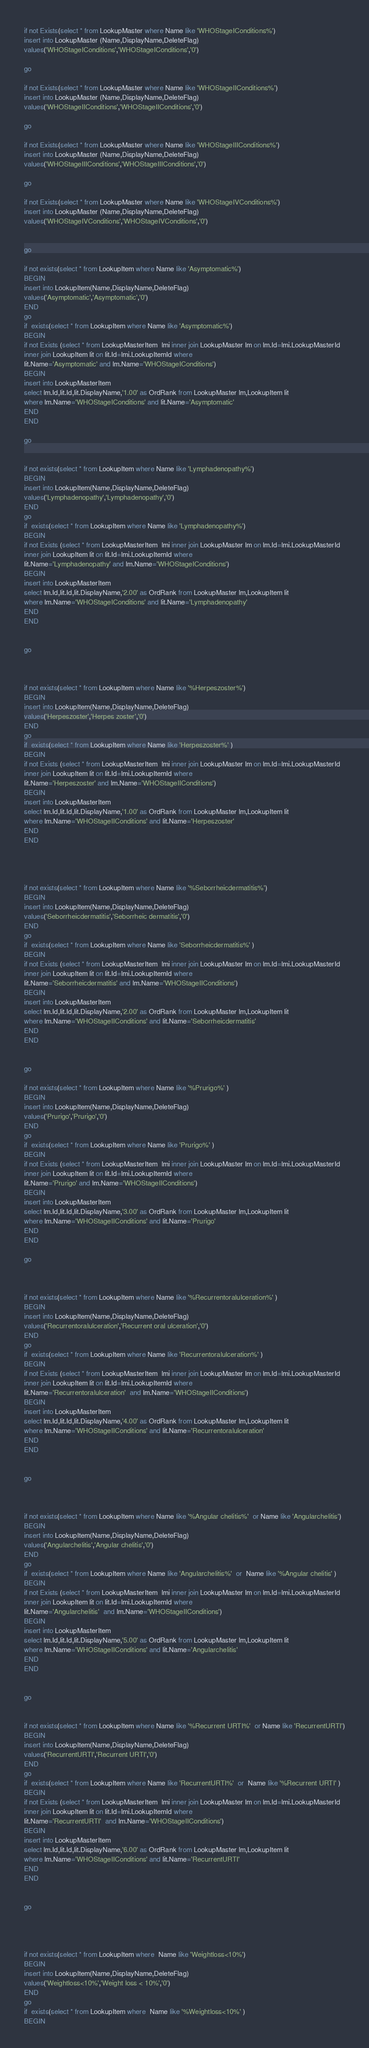<code> <loc_0><loc_0><loc_500><loc_500><_SQL_>if not Exists(select * from LookupMaster where Name like 'WHOStageIConditions%')
insert into LookupMaster (Name,DisplayName,DeleteFlag)
values('WHOStageIConditions','WHOStageIConditions','0')

go

if not Exists(select * from LookupMaster where Name like 'WHOStageIIConditions%')
insert into LookupMaster (Name,DisplayName,DeleteFlag)
values('WHOStageIIConditions','WHOStageIIConditions','0')

go

if not Exists(select * from LookupMaster where Name like 'WHOStageIIIConditions%')
insert into LookupMaster (Name,DisplayName,DeleteFlag)
values('WHOStageIIIConditions','WHOStageIIIConditions','0')

go

if not Exists(select * from LookupMaster where Name like 'WHOStageIVConditions%')
insert into LookupMaster (Name,DisplayName,DeleteFlag)
values('WHOStageIVConditions','WHOStageIVConditions','0')


go

if not exists(select * from LookupItem where Name like 'Asymptomatic%')
BEGIN
insert into LookupItem(Name,DisplayName,DeleteFlag)
values('Asymptomatic','Asymptomatic','0')
END
go
if  exists(select * from LookupItem where Name like 'Asymptomatic%')
BEGIN
if not Exists (select * from LookupMasterItem  lmi inner join LookupMaster lm on lm.Id=lmi.LookupMasterId
inner join LookupItem lit on lit.Id=lmi.LookupItemId where 
lit.Name='Asymptomatic' and lm.Name='WHOStageIConditions')
BEGIN
insert into LookupMasterItem 
select lm.Id,lit.Id,lit.DisplayName,'1.00' as OrdRank from LookupMaster lm,LookupItem lit
where lm.Name='WHOStageIConditions' and lit.Name='Asymptomatic'
END
END

go


if not exists(select * from LookupItem where Name like 'Lymphadenopathy%')
BEGIN
insert into LookupItem(Name,DisplayName,DeleteFlag)
values('Lymphadenopathy','Lymphadenopathy','0')
END
go
if  exists(select * from LookupItem where Name like 'Lymphadenopathy%')
BEGIN
if not Exists (select * from LookupMasterItem  lmi inner join LookupMaster lm on lm.Id=lmi.LookupMasterId
inner join LookupItem lit on lit.Id=lmi.LookupItemId where 
lit.Name='Lymphadenopathy' and lm.Name='WHOStageIConditions')
BEGIN
insert into LookupMasterItem 
select lm.Id,lit.Id,lit.DisplayName,'2.00' as OrdRank from LookupMaster lm,LookupItem lit
where lm.Name='WHOStageIConditions' and lit.Name='Lymphadenopathy'
END
END


go



if not exists(select * from LookupItem where Name like '%Herpeszoster%')
BEGIN
insert into LookupItem(Name,DisplayName,DeleteFlag)
values('Herpeszoster','Herpes zoster','0')
END
go
if  exists(select * from LookupItem where Name like 'Herpeszoster%' )
BEGIN
if not Exists (select * from LookupMasterItem  lmi inner join LookupMaster lm on lm.Id=lmi.LookupMasterId
inner join LookupItem lit on lit.Id=lmi.LookupItemId where 
lit.Name='Herpeszoster' and lm.Name='WHOStageIIConditions')
BEGIN
insert into LookupMasterItem 
select lm.Id,lit.Id,lit.DisplayName,'1.00' as OrdRank from LookupMaster lm,LookupItem lit
where lm.Name='WHOStageIIConditions' and lit.Name='Herpeszoster'
END
END




if not exists(select * from LookupItem where Name like '%Seborrheicdermatitis%')
BEGIN
insert into LookupItem(Name,DisplayName,DeleteFlag)
values('Seborrheicdermatitis','Seborrheic dermatitis','0')
END
go
if  exists(select * from LookupItem where Name like 'Seborrheicdermatitis%' )
BEGIN
if not Exists (select * from LookupMasterItem  lmi inner join LookupMaster lm on lm.Id=lmi.LookupMasterId
inner join LookupItem lit on lit.Id=lmi.LookupItemId where 
lit.Name='Seborrheicdermatitis' and lm.Name='WHOStageIIConditions')
BEGIN
insert into LookupMasterItem 
select lm.Id,lit.Id,lit.DisplayName,'2.00' as OrdRank from LookupMaster lm,LookupItem lit
where lm.Name='WHOStageIIConditions' and lit.Name='Seborrheicdermatitis'
END
END


go

if not exists(select * from LookupItem where Name like '%Prurigo%' )
BEGIN
insert into LookupItem(Name,DisplayName,DeleteFlag)
values('Prurigo','Prurigo','0')
END
go
if  exists(select * from LookupItem where Name like 'Prurigo%' )
BEGIN
if not Exists (select * from LookupMasterItem  lmi inner join LookupMaster lm on lm.Id=lmi.LookupMasterId
inner join LookupItem lit on lit.Id=lmi.LookupItemId where 
lit.Name='Prurigo' and lm.Name='WHOStageIIConditions')
BEGIN
insert into LookupMasterItem 
select lm.Id,lit.Id,lit.DisplayName,'3.00' as OrdRank from LookupMaster lm,LookupItem lit
where lm.Name='WHOStageIIConditions' and lit.Name='Prurigo'
END
END

go



if not exists(select * from LookupItem where Name like '%Recurrentoralulceration%' )
BEGIN
insert into LookupItem(Name,DisplayName,DeleteFlag)
values('Recurrentoralulceration','Recurrent oral ulceration','0')
END
go
if  exists(select * from LookupItem where Name like 'Recurrentoralulceration%' )
BEGIN
if not Exists (select * from LookupMasterItem  lmi inner join LookupMaster lm on lm.Id=lmi.LookupMasterId
inner join LookupItem lit on lit.Id=lmi.LookupItemId where 
lit.Name='Recurrentoralulceration'  and lm.Name='WHOStageIIConditions')
BEGIN
insert into LookupMasterItem 
select lm.Id,lit.Id,lit.DisplayName,'4.00' as OrdRank from LookupMaster lm,LookupItem lit
where lm.Name='WHOStageIIConditions' and lit.Name='Recurrentoralulceration' 
END
END


go



if not exists(select * from LookupItem where Name like '%Angular chelitis%'  or Name like 'Angularchelitis')
BEGIN
insert into LookupItem(Name,DisplayName,DeleteFlag)
values('Angularchelitis','Angular chelitis','0')
END
go
if  exists(select * from LookupItem where Name like 'Angularchelitis%'  or  Name like '%Angular chelitis' )
BEGIN
if not Exists (select * from LookupMasterItem  lmi inner join LookupMaster lm on lm.Id=lmi.LookupMasterId
inner join LookupItem lit on lit.Id=lmi.LookupItemId where 
lit.Name='Angularchelitis'  and lm.Name='WHOStageIIConditions')
BEGIN
insert into LookupMasterItem 
select lm.Id,lit.Id,lit.DisplayName,'5.00' as OrdRank from LookupMaster lm,LookupItem lit
where lm.Name='WHOStageIIConditions' and lit.Name='Angularchelitis' 
END
END


go


if not exists(select * from LookupItem where Name like '%Recurrent URTI%'  or Name like 'RecurrentURTI')
BEGIN
insert into LookupItem(Name,DisplayName,DeleteFlag)
values('RecurrentURTI','Recurrent URTI','0')
END
go
if  exists(select * from LookupItem where Name like 'RecurrentURTI%'  or  Name like '%Recurrent URTI' )
BEGIN
if not Exists (select * from LookupMasterItem  lmi inner join LookupMaster lm on lm.Id=lmi.LookupMasterId
inner join LookupItem lit on lit.Id=lmi.LookupItemId where 
lit.Name='RecurrentURTI'  and lm.Name='WHOStageIIConditions')
BEGIN
insert into LookupMasterItem 
select lm.Id,lit.Id,lit.DisplayName,'6.00' as OrdRank from LookupMaster lm,LookupItem lit
where lm.Name='WHOStageIIConditions' and lit.Name='RecurrentURTI' 
END
END


go




if not exists(select * from LookupItem where  Name like 'Weightloss<10%')
BEGIN
insert into LookupItem(Name,DisplayName,DeleteFlag)
values('Weightloss<10%','Weight loss < 10%','0')
END
go
if  exists(select * from LookupItem where  Name like '%Weightloss<10%' )
BEGIN</code> 